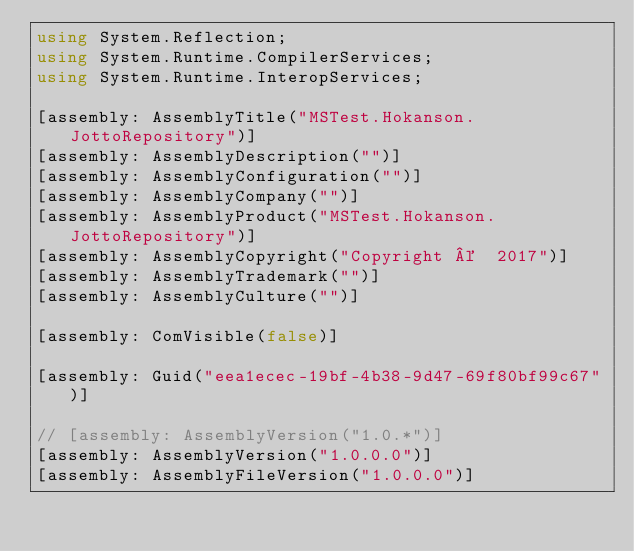<code> <loc_0><loc_0><loc_500><loc_500><_C#_>using System.Reflection;
using System.Runtime.CompilerServices;
using System.Runtime.InteropServices;

[assembly: AssemblyTitle("MSTest.Hokanson.JottoRepository")]
[assembly: AssemblyDescription("")]
[assembly: AssemblyConfiguration("")]
[assembly: AssemblyCompany("")]
[assembly: AssemblyProduct("MSTest.Hokanson.JottoRepository")]
[assembly: AssemblyCopyright("Copyright ©  2017")]
[assembly: AssemblyTrademark("")]
[assembly: AssemblyCulture("")]

[assembly: ComVisible(false)]

[assembly: Guid("eea1ecec-19bf-4b38-9d47-69f80bf99c67")]

// [assembly: AssemblyVersion("1.0.*")]
[assembly: AssemblyVersion("1.0.0.0")]
[assembly: AssemblyFileVersion("1.0.0.0")]
</code> 